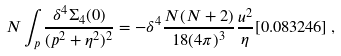<formula> <loc_0><loc_0><loc_500><loc_500>N \int _ { p } \frac { \delta ^ { 4 } \Sigma _ { 4 } ( 0 ) } { ( p ^ { 2 } + \eta ^ { 2 } ) ^ { 2 } } = - \delta ^ { 4 } \frac { N ( N + 2 ) } { 1 8 ( 4 \pi ) ^ { 3 } } \frac { u ^ { 2 } } { \eta } [ 0 . 0 8 3 2 4 6 ] \, ,</formula> 